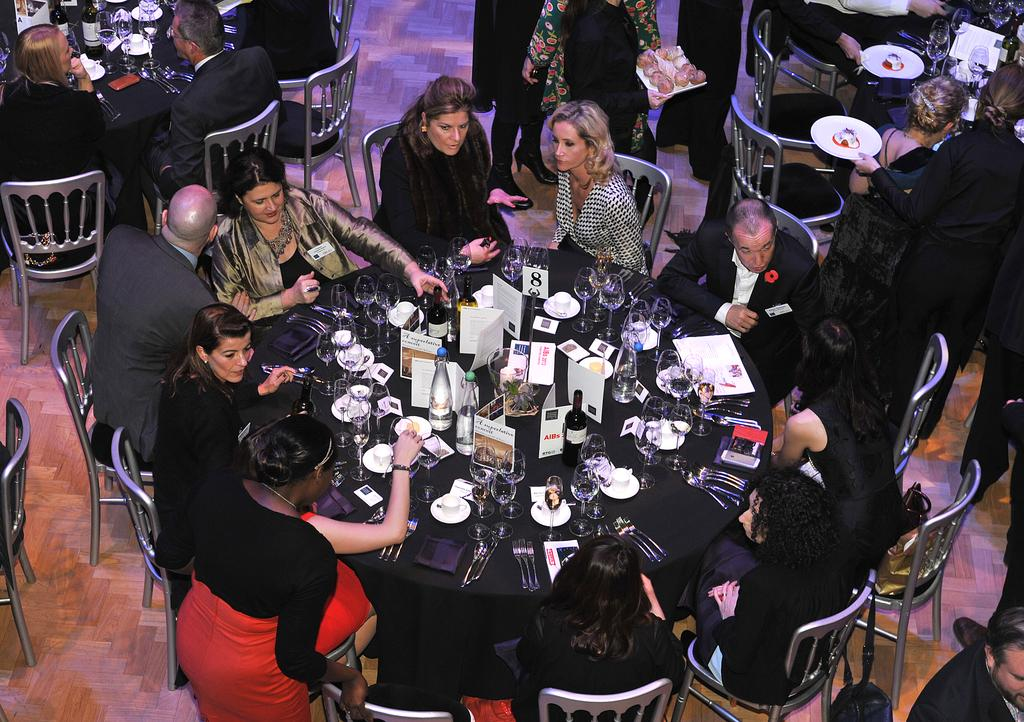How many people are in the image? There is a group of people in the image, but the exact number is not specified. What are the people in the image doing? The people are sitting in the image. What type of objects can be seen in the image? There are bottles, glasses, and spoons visible in the image. What is on the table in the image? There are objects on the table in the image, but their specific nature is not mentioned. What type of beef is being served at the table in the image? There is no beef present in the image; the objects on the table are not specified. What is the profit margin of the people in the image? There is no information about profit margins in the image; it only shows a group of people sitting and various objects. 